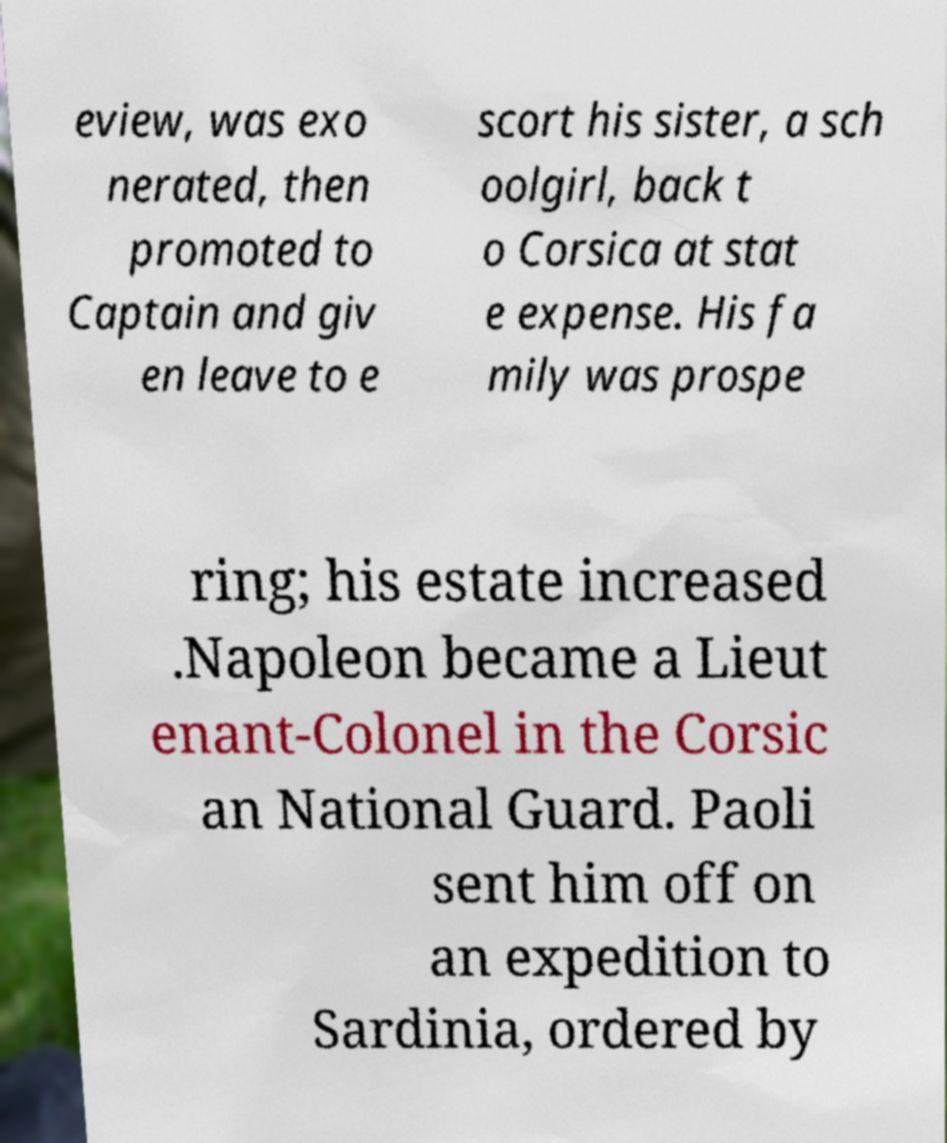I need the written content from this picture converted into text. Can you do that? eview, was exo nerated, then promoted to Captain and giv en leave to e scort his sister, a sch oolgirl, back t o Corsica at stat e expense. His fa mily was prospe ring; his estate increased .Napoleon became a Lieut enant-Colonel in the Corsic an National Guard. Paoli sent him off on an expedition to Sardinia, ordered by 